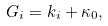<formula> <loc_0><loc_0><loc_500><loc_500>G _ { i } = k _ { i } + \kappa _ { 0 } ,</formula> 